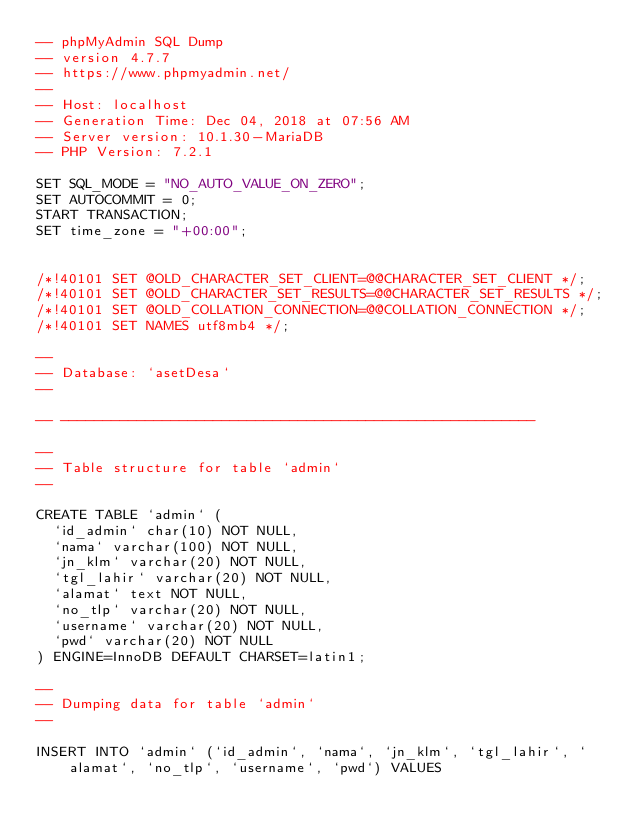Convert code to text. <code><loc_0><loc_0><loc_500><loc_500><_SQL_>-- phpMyAdmin SQL Dump
-- version 4.7.7
-- https://www.phpmyadmin.net/
--
-- Host: localhost
-- Generation Time: Dec 04, 2018 at 07:56 AM
-- Server version: 10.1.30-MariaDB
-- PHP Version: 7.2.1

SET SQL_MODE = "NO_AUTO_VALUE_ON_ZERO";
SET AUTOCOMMIT = 0;
START TRANSACTION;
SET time_zone = "+00:00";


/*!40101 SET @OLD_CHARACTER_SET_CLIENT=@@CHARACTER_SET_CLIENT */;
/*!40101 SET @OLD_CHARACTER_SET_RESULTS=@@CHARACTER_SET_RESULTS */;
/*!40101 SET @OLD_COLLATION_CONNECTION=@@COLLATION_CONNECTION */;
/*!40101 SET NAMES utf8mb4 */;

--
-- Database: `asetDesa`
--

-- --------------------------------------------------------

--
-- Table structure for table `admin`
--

CREATE TABLE `admin` (
  `id_admin` char(10) NOT NULL,
  `nama` varchar(100) NOT NULL,
  `jn_klm` varchar(20) NOT NULL,
  `tgl_lahir` varchar(20) NOT NULL,
  `alamat` text NOT NULL,
  `no_tlp` varchar(20) NOT NULL,
  `username` varchar(20) NOT NULL,
  `pwd` varchar(20) NOT NULL
) ENGINE=InnoDB DEFAULT CHARSET=latin1;

--
-- Dumping data for table `admin`
--

INSERT INTO `admin` (`id_admin`, `nama`, `jn_klm`, `tgl_lahir`, `alamat`, `no_tlp`, `username`, `pwd`) VALUES</code> 